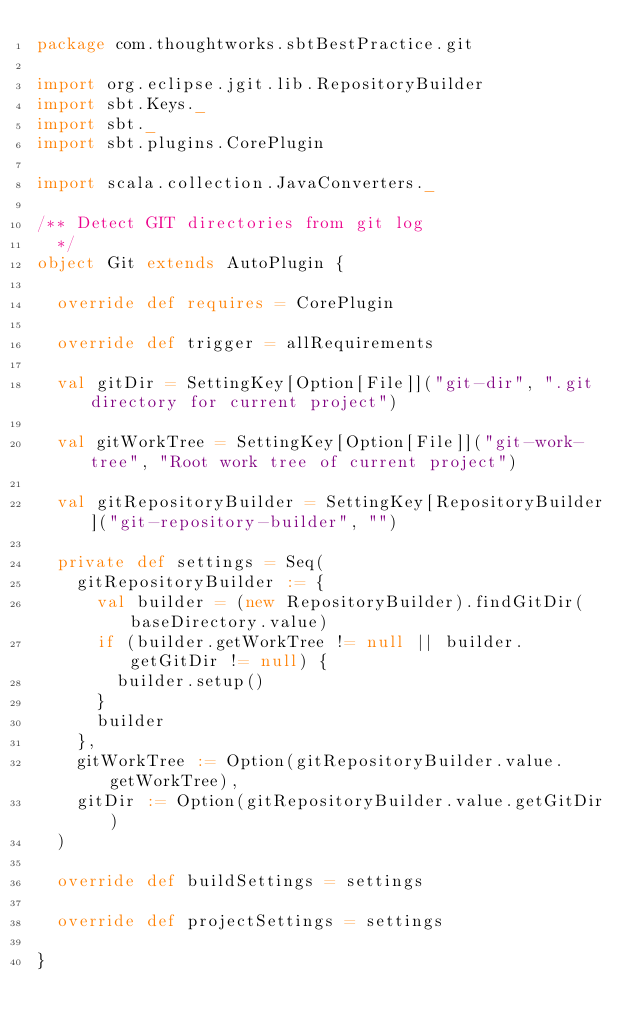<code> <loc_0><loc_0><loc_500><loc_500><_Scala_>package com.thoughtworks.sbtBestPractice.git

import org.eclipse.jgit.lib.RepositoryBuilder
import sbt.Keys._
import sbt._
import sbt.plugins.CorePlugin

import scala.collection.JavaConverters._

/** Detect GIT directories from git log
  */
object Git extends AutoPlugin {

  override def requires = CorePlugin

  override def trigger = allRequirements

  val gitDir = SettingKey[Option[File]]("git-dir", ".git directory for current project")

  val gitWorkTree = SettingKey[Option[File]]("git-work-tree", "Root work tree of current project")

  val gitRepositoryBuilder = SettingKey[RepositoryBuilder]("git-repository-builder", "")

  private def settings = Seq(
    gitRepositoryBuilder := {
      val builder = (new RepositoryBuilder).findGitDir(baseDirectory.value)
      if (builder.getWorkTree != null || builder.getGitDir != null) {
        builder.setup()
      }
      builder
    },
    gitWorkTree := Option(gitRepositoryBuilder.value.getWorkTree),
    gitDir := Option(gitRepositoryBuilder.value.getGitDir)
  )

  override def buildSettings = settings

  override def projectSettings = settings

}
</code> 